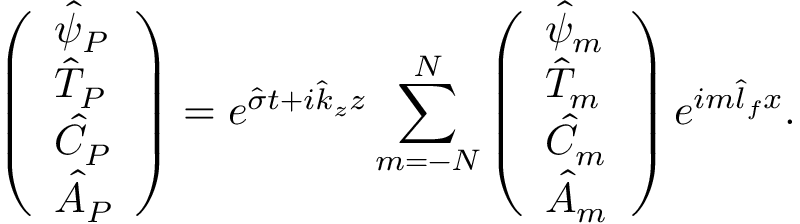<formula> <loc_0><loc_0><loc_500><loc_500>\left ( \begin{array} { l } { \hat { \psi } _ { P } } \\ { \hat { T } _ { P } } \\ { \hat { C } _ { P } } \\ { \hat { A } _ { P } } \end{array} \right ) = e ^ { \hat { \sigma } t + i \hat { k } _ { z } z } \sum _ { m = - N } ^ { N } \left ( \begin{array} { l } { \hat { \psi } _ { m } } \\ { \hat { T } _ { m } } \\ { \hat { C } _ { m } } \\ { \hat { A } _ { m } } \end{array} \right ) e ^ { i m \hat { l } _ { f } x } .</formula> 